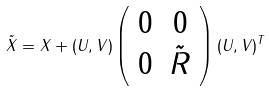<formula> <loc_0><loc_0><loc_500><loc_500>\tilde { X } = X + ( U , V ) \left ( \begin{array} { c c } 0 & 0 \\ 0 & \tilde { R } \end{array} \right ) ( U , V ) ^ { T }</formula> 